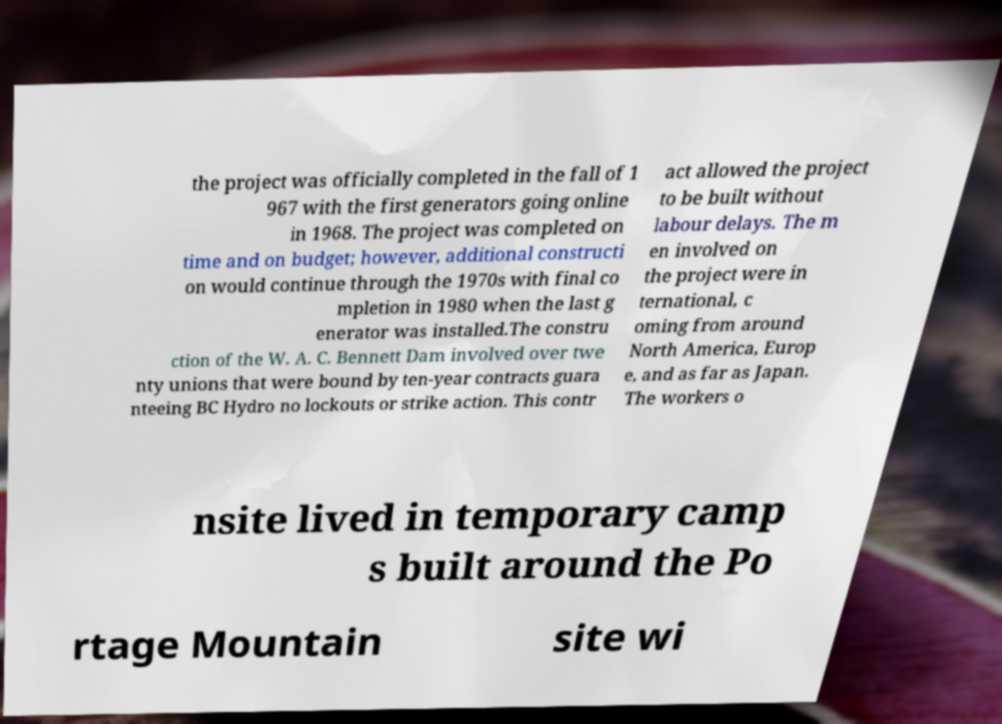Could you assist in decoding the text presented in this image and type it out clearly? the project was officially completed in the fall of 1 967 with the first generators going online in 1968. The project was completed on time and on budget; however, additional constructi on would continue through the 1970s with final co mpletion in 1980 when the last g enerator was installed.The constru ction of the W. A. C. Bennett Dam involved over twe nty unions that were bound by ten-year contracts guara nteeing BC Hydro no lockouts or strike action. This contr act allowed the project to be built without labour delays. The m en involved on the project were in ternational, c oming from around North America, Europ e, and as far as Japan. The workers o nsite lived in temporary camp s built around the Po rtage Mountain site wi 